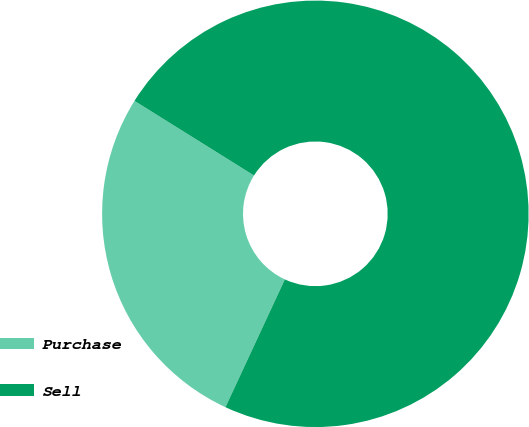<chart> <loc_0><loc_0><loc_500><loc_500><pie_chart><fcel>Purchase<fcel>Sell<nl><fcel>26.96%<fcel>73.04%<nl></chart> 